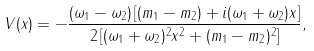Convert formula to latex. <formula><loc_0><loc_0><loc_500><loc_500>V ( x ) = - \frac { ( \omega _ { 1 } - \omega _ { 2 } ) \left [ ( m _ { 1 } - m _ { 2 } ) + i ( \omega _ { 1 } + \omega _ { 2 } ) x \right ] } { 2 \left [ ( \omega _ { 1 } + \omega _ { 2 } ) ^ { 2 } x ^ { 2 } + ( m _ { 1 } - m _ { 2 } ) ^ { 2 } \right ] } ,</formula> 